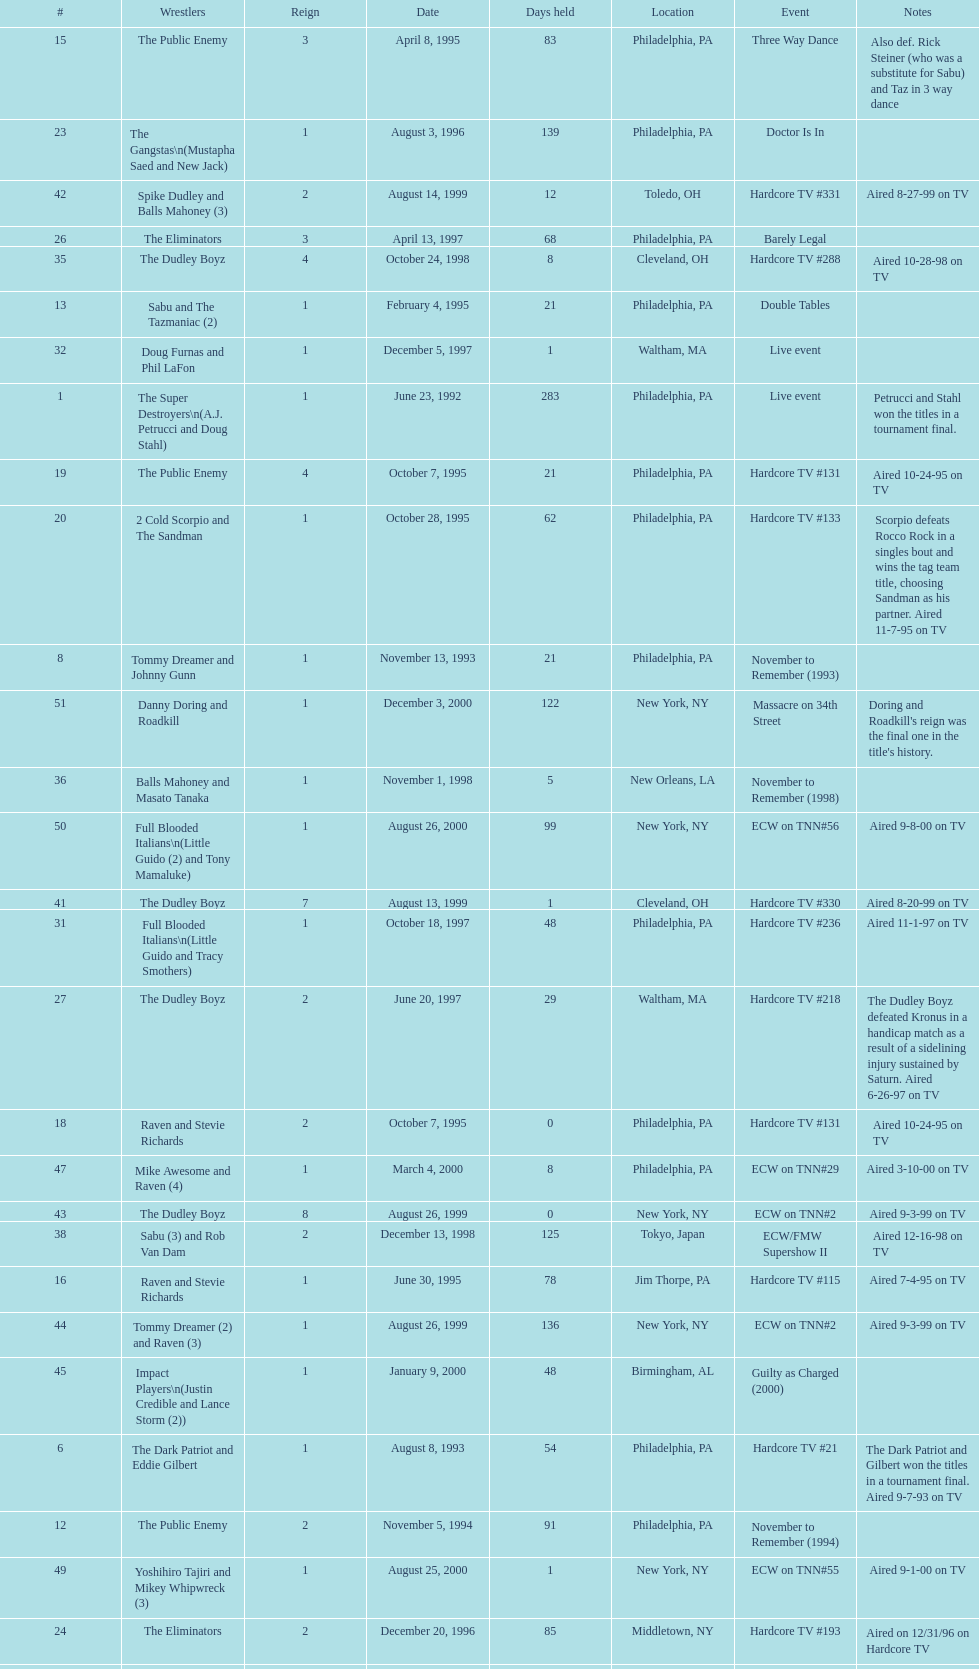Which occurrence precedes hardcore tv episode 14? Hardcore TV #8. Can you give me this table as a dict? {'header': ['#', 'Wrestlers', 'Reign', 'Date', 'Days held', 'Location', 'Event', 'Notes'], 'rows': [['15', 'The Public Enemy', '3', 'April 8, 1995', '83', 'Philadelphia, PA', 'Three Way Dance', 'Also def. Rick Steiner (who was a substitute for Sabu) and Taz in 3 way dance'], ['23', 'The Gangstas\\n(Mustapha Saed and New Jack)', '1', 'August 3, 1996', '139', 'Philadelphia, PA', 'Doctor Is In', ''], ['42', 'Spike Dudley and Balls Mahoney (3)', '2', 'August 14, 1999', '12', 'Toledo, OH', 'Hardcore TV #331', 'Aired 8-27-99 on TV'], ['26', 'The Eliminators', '3', 'April 13, 1997', '68', 'Philadelphia, PA', 'Barely Legal', ''], ['35', 'The Dudley Boyz', '4', 'October 24, 1998', '8', 'Cleveland, OH', 'Hardcore TV #288', 'Aired 10-28-98 on TV'], ['13', 'Sabu and The Tazmaniac (2)', '1', 'February 4, 1995', '21', 'Philadelphia, PA', 'Double Tables', ''], ['32', 'Doug Furnas and Phil LaFon', '1', 'December 5, 1997', '1', 'Waltham, MA', 'Live event', ''], ['1', 'The Super Destroyers\\n(A.J. Petrucci and Doug Stahl)', '1', 'June 23, 1992', '283', 'Philadelphia, PA', 'Live event', 'Petrucci and Stahl won the titles in a tournament final.'], ['19', 'The Public Enemy', '4', 'October 7, 1995', '21', 'Philadelphia, PA', 'Hardcore TV #131', 'Aired 10-24-95 on TV'], ['20', '2 Cold Scorpio and The Sandman', '1', 'October 28, 1995', '62', 'Philadelphia, PA', 'Hardcore TV #133', 'Scorpio defeats Rocco Rock in a singles bout and wins the tag team title, choosing Sandman as his partner. Aired 11-7-95 on TV'], ['8', 'Tommy Dreamer and Johnny Gunn', '1', 'November 13, 1993', '21', 'Philadelphia, PA', 'November to Remember (1993)', ''], ['51', 'Danny Doring and Roadkill', '1', 'December 3, 2000', '122', 'New York, NY', 'Massacre on 34th Street', "Doring and Roadkill's reign was the final one in the title's history."], ['36', 'Balls Mahoney and Masato Tanaka', '1', 'November 1, 1998', '5', 'New Orleans, LA', 'November to Remember (1998)', ''], ['50', 'Full Blooded Italians\\n(Little Guido (2) and Tony Mamaluke)', '1', 'August 26, 2000', '99', 'New York, NY', 'ECW on TNN#56', 'Aired 9-8-00 on TV'], ['41', 'The Dudley Boyz', '7', 'August 13, 1999', '1', 'Cleveland, OH', 'Hardcore TV #330', 'Aired 8-20-99 on TV'], ['31', 'Full Blooded Italians\\n(Little Guido and Tracy Smothers)', '1', 'October 18, 1997', '48', 'Philadelphia, PA', 'Hardcore TV #236', 'Aired 11-1-97 on TV'], ['27', 'The Dudley Boyz', '2', 'June 20, 1997', '29', 'Waltham, MA', 'Hardcore TV #218', 'The Dudley Boyz defeated Kronus in a handicap match as a result of a sidelining injury sustained by Saturn. Aired 6-26-97 on TV'], ['18', 'Raven and Stevie Richards', '2', 'October 7, 1995', '0', 'Philadelphia, PA', 'Hardcore TV #131', 'Aired 10-24-95 on TV'], ['47', 'Mike Awesome and Raven (4)', '1', 'March 4, 2000', '8', 'Philadelphia, PA', 'ECW on TNN#29', 'Aired 3-10-00 on TV'], ['43', 'The Dudley Boyz', '8', 'August 26, 1999', '0', 'New York, NY', 'ECW on TNN#2', 'Aired 9-3-99 on TV'], ['38', 'Sabu (3) and Rob Van Dam', '2', 'December 13, 1998', '125', 'Tokyo, Japan', 'ECW/FMW Supershow II', 'Aired 12-16-98 on TV'], ['16', 'Raven and Stevie Richards', '1', 'June 30, 1995', '78', 'Jim Thorpe, PA', 'Hardcore TV #115', 'Aired 7-4-95 on TV'], ['44', 'Tommy Dreamer (2) and Raven (3)', '1', 'August 26, 1999', '136', 'New York, NY', 'ECW on TNN#2', 'Aired 9-3-99 on TV'], ['45', 'Impact Players\\n(Justin Credible and Lance Storm (2))', '1', 'January 9, 2000', '48', 'Birmingham, AL', 'Guilty as Charged (2000)', ''], ['6', 'The Dark Patriot and Eddie Gilbert', '1', 'August 8, 1993', '54', 'Philadelphia, PA', 'Hardcore TV #21', 'The Dark Patriot and Gilbert won the titles in a tournament final. Aired 9-7-93 on TV'], ['12', 'The Public Enemy', '2', 'November 5, 1994', '91', 'Philadelphia, PA', 'November to Remember (1994)', ''], ['49', 'Yoshihiro Tajiri and Mikey Whipwreck (3)', '1', 'August 25, 2000', '1', 'New York, NY', 'ECW on TNN#55', 'Aired 9-1-00 on TV'], ['24', 'The Eliminators', '2', 'December 20, 1996', '85', 'Middletown, NY', 'Hardcore TV #193', 'Aired on 12/31/96 on Hardcore TV'], ['40', 'Spike Dudley and Balls Mahoney (2)', '1', 'July 18, 1999', '26', 'Dayton, OH', 'Heat Wave (1999)', ''], ['4', 'The Super Destroyers', '2', 'May 15, 1993', '0', 'Philadelphia, PA', 'Hardcore TV #14', 'Aired 7-6-93 on TV'], ['46', 'Tommy Dreamer (3) and Masato Tanaka (2)', '1', 'February 26, 2000', '7', 'Cincinnati, OH', 'Hardcore TV #358', 'Aired 3-7-00 on TV'], ['37', 'The Dudley Boyz', '5', 'November 6, 1998', '37', 'New York, NY', 'Hardcore TV #290', 'Aired 11-11-98 on TV'], ['—', 'Vacated', '2', 'October 1, 1993', '0', 'Philadelphia, PA', 'Bloodfest: Part 1', 'ECW vacated the championships after The Dark Patriot and Eddie Gilbert left the organization.'], ['14', 'Chris Benoit and Dean Malenko', '1', 'February 25, 1995', '42', 'Philadelphia, PA', 'Return of the Funker', ''], ['21', 'Cactus Jack and Mikey Whipwreck', '2', 'December 29, 1995', '36', 'New York, NY', 'Holiday Hell 1995', "Whipwreck defeated 2 Cold Scorpio in a singles match to win both the tag team titles and the ECW World Television Championship; Cactus Jack came out and declared himself to be Mikey's partner after he won the match."], ['48', 'Impact Players\\n(Justin Credible and Lance Storm (3))', '2', 'March 12, 2000', '31', 'Danbury, CT', 'Living Dangerously', ''], ['22', 'The Eliminators\\n(Kronus and Saturn)', '1', 'February 3, 1996', '182', 'New York, NY', 'Big Apple Blizzard Blast', ''], ['17', 'The Pitbulls\\n(Pitbull #1 and Pitbull #2)', '1', 'September 16, 1995', '21', 'Philadelphia, PA', "Gangsta's Paradise", ''], ['10', 'The Public Enemy\\n(Johnny Grunge and Rocco Rock)', '1', 'March 6, 1994', '174', 'Philadelphia, PA', 'Hardcore TV #46', 'Aired 3-8-94 on TV'], ['29', 'The Dudley Boyz', '3', 'August 17, 1997', '95', 'Fort Lauderdale, FL', 'Hardcore Heaven (1997)', 'The Dudley Boyz won the championship via forfeit as a result of Mustapha Saed leaving the promotion before Hardcore Heaven took place.'], ['33', 'Chris Candido (3) and Lance Storm', '1', 'December 6, 1997', '203', 'Philadelphia, PA', 'Better than Ever', ''], ['5', 'The Suicide Blondes', '2', 'May 15, 1993', '46', 'Philadelphia, PA', 'Hardcore TV #15', 'Aired 7-20-93 on TV'], ['—', 'Vacated', '1', 'July 1993', '39', 'N/A', 'N/A', 'ECW vacated the title after Candido left the promotion for the Smoky Mountain Wrestling organization.'], ['3', 'The Suicide Blondes\\n(Chris Candido, Johnny Hotbody, and Chris Michaels)', '1', 'April 3, 1993', '42', 'Philadelphia, PA', 'Hardcore TV #8', 'All three wrestlers were recognized as champions, and were able to defend the titles in any combination via the Freebird rule. Aired 5-25-93 on TV'], ['25', 'The Dudley Boyz\\n(Buh Buh Ray Dudley and D-Von Dudley)', '1', 'March 15, 1997', '29', 'Philadelphia, PA', 'Hostile City Showdown', 'Aired 3/20/97 on Hardcore TV'], ['39', 'The Dudley Boyz', '6', 'April 17, 1999', '92', 'Buffalo, NY', 'Hardcore TV #313', 'D-Von Dudley defeated Van Dam in a singles match to win the championship for his team. Aired 4-23-99 on TV'], ['11', 'Cactus Jack and Mikey Whipwreck', '1', 'August 27, 1994', '70', 'Philadelphia, PA', 'Hardcore TV #72', 'Whipwreck was a substitute for Terry Funk, who left the company. Aired 9-13-94 on TV'], ['34', 'Sabu (2) and Rob Van Dam', '1', 'June 27, 1998', '119', 'Philadelphia, PA', 'Hardcore TV #271', 'Aired 7-1-98 on TV'], ['7', 'Johnny Hotbody (3) and Tony Stetson (2)', '1', 'October 1, 1993', '43', 'Philadelphia, PA', 'Bloodfest: Part 1', 'Hotbody and Stetson were awarded the titles by ECW.'], ['28', 'The Gangstas', '2', 'July 19, 1997', '29', 'Philadelphia, PA', 'Heat Wave 1997/Hardcore TV #222', 'Aired 7-24-97 on TV'], ['9', 'Kevin Sullivan and The Tazmaniac', '1', 'December 4, 1993', '92', 'Philadelphia, PA', 'Hardcore TV #35', 'Defeat Dreamer and Shane Douglas, who was substituting for an injured Gunn. After the bout, Douglas turned against Dreamer and became a heel. Aired 12-14-93 on TV'], ['2', 'Tony Stetson and Larry Winters', '1', 'April 2, 1993', '1', 'Radnor, PA', 'Hardcore TV #6', 'Aired 5-11-93 on TV'], ['—', 'Vacated', '3', 'April 22, 2000', '125', 'Philadelphia, PA', 'Live event', 'At CyberSlam, Justin Credible threw down the titles to become eligible for the ECW World Heavyweight Championship. Storm later left for World Championship Wrestling. As a result of the circumstances, Credible vacated the championship.'], ['30', 'The Gangstanators\\n(Kronus (4) and New Jack (3))', '1', 'September 20, 1997', '28', 'Philadelphia, PA', 'As Good as it Gets', 'Aired 9-27-97 on TV']]} 